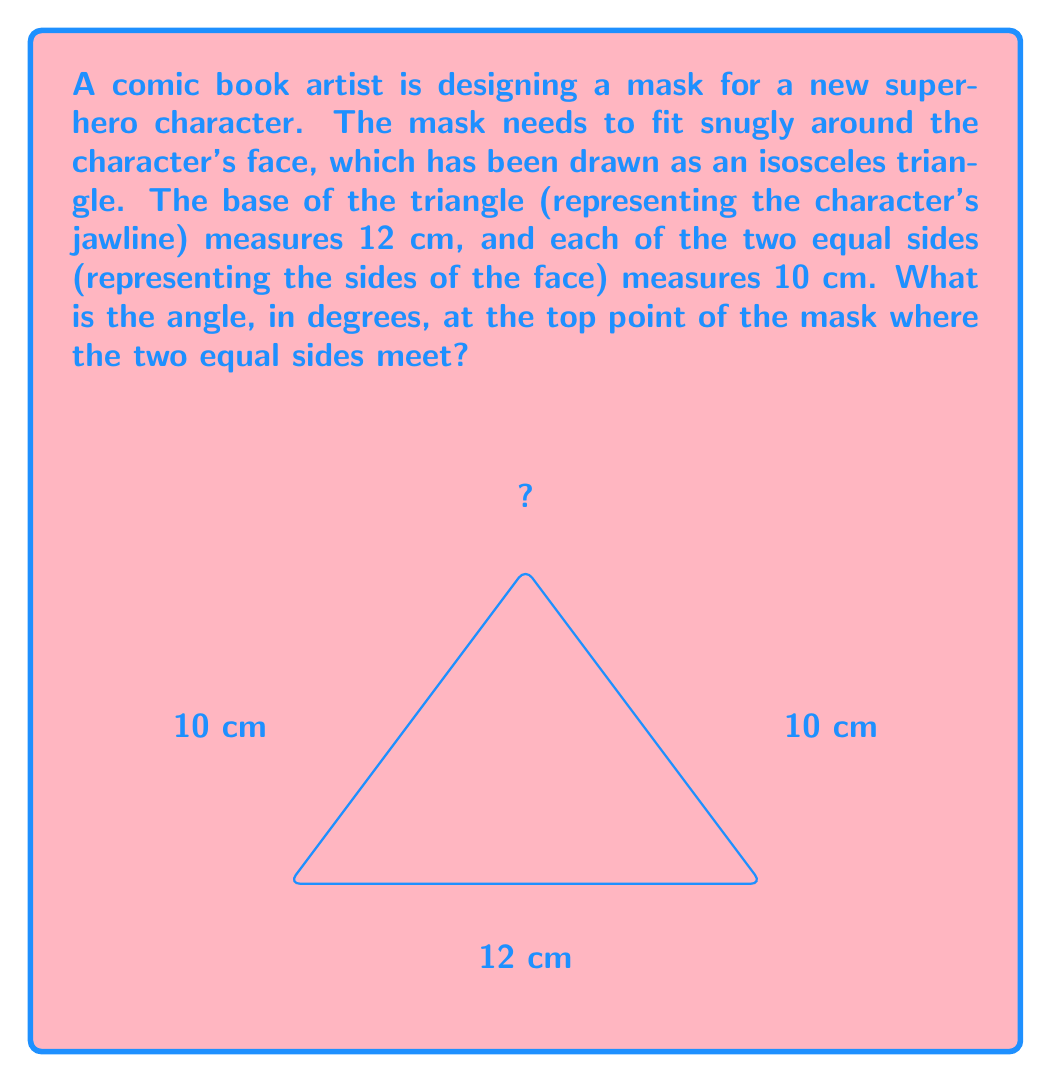What is the answer to this math problem? Let's approach this step-by-step:

1) We have an isosceles triangle where two sides are equal (10 cm each) and the base is 12 cm.

2) To find the angle at the top, we can use the cosine law:

   $$ c^2 = a^2 + b^2 - 2ab \cos(C) $$

   Where $C$ is the angle we're looking for, and $c$ is the base of the triangle.

3) Substituting our known values:

   $$ 12^2 = 10^2 + 10^2 - 2(10)(10) \cos(C) $$

4) Simplify:

   $$ 144 = 100 + 100 - 200 \cos(C) $$
   $$ 144 = 200 - 200 \cos(C) $$

5) Subtract 200 from both sides:

   $$ -56 = -200 \cos(C) $$

6) Divide both sides by -200:

   $$ \frac{56}{200} = \cos(C) $$
   $$ 0.28 = \cos(C) $$

7) To find $C$, we need to take the inverse cosine (arccos) of both sides:

   $$ C = \arccos(0.28) $$

8) Using a calculator or trigonometric tables:

   $$ C \approx 73.74^\circ $$

Therefore, the angle at the top of the mask should be approximately 73.74°.
Answer: $73.74^\circ$ 